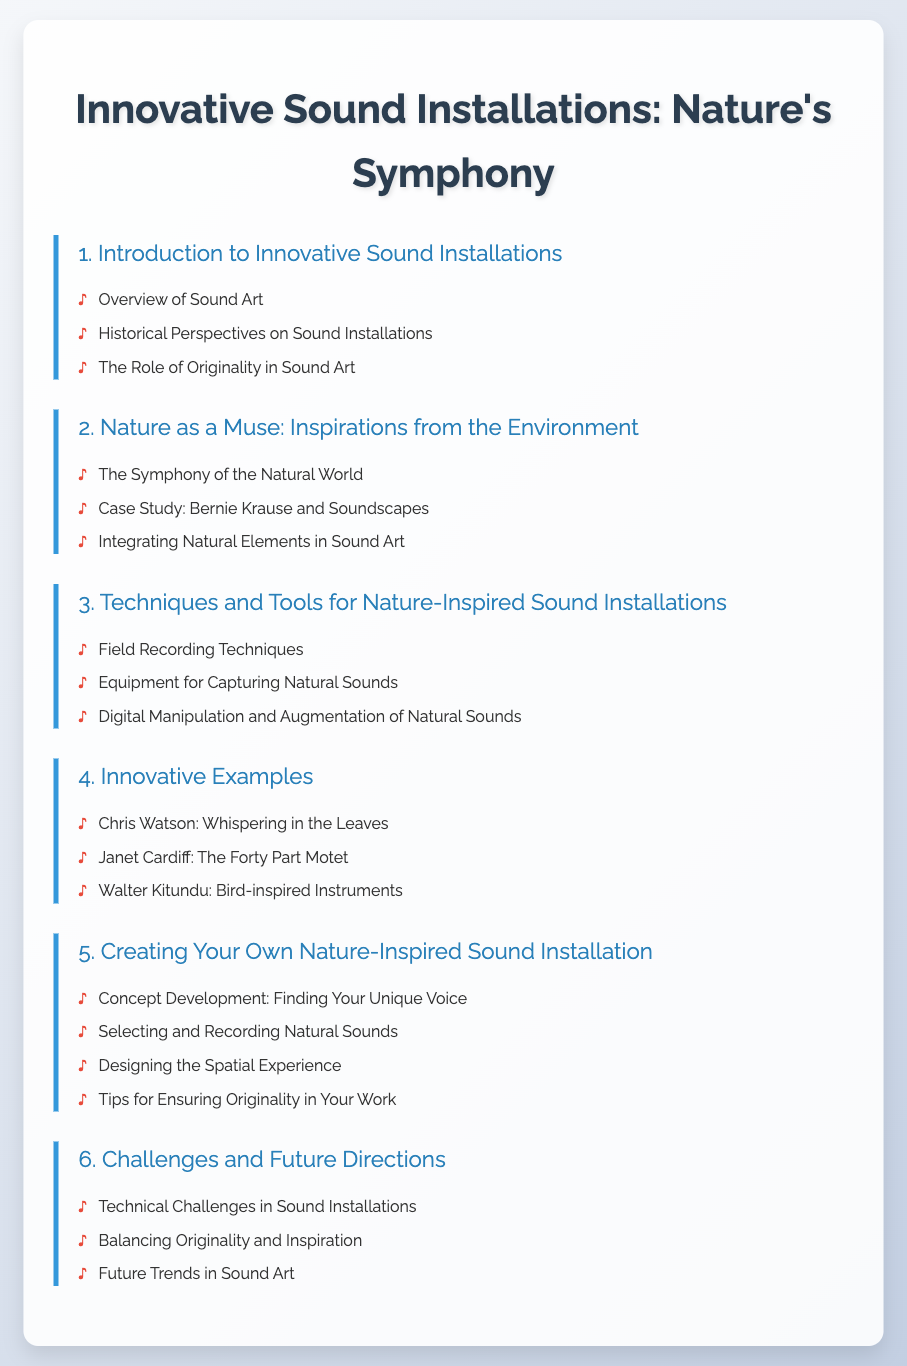what is the title of the document? The title listed at the top of the document clearly shows the main focus area it covers, which is "Innovative Sound Installations: Nature's Symphony."
Answer: Innovative Sound Installations: Nature's Symphony how many chapters are in the document? By counting the number of distinct chapters provided in the Table of Contents, you can determine the total, which is six.
Answer: 6 who is a case study highlighted in the second chapter? The document specifically mentions Bernie Krause in the context of soundscapes in the second chapter.
Answer: Bernie Krause what is covered in the fourth chapter? The fourth chapter focuses on innovative examples of sound installations, detailing specific artists and their work.
Answer: Innovative Examples which section emphasizes originality? The document mentions originality in both Chapter 1 and Chapter 5, highlighting its significance in sound art and practical creation.
Answer: The Role of Originality in Sound Art what is a technique mentioned for capturing natural sounds? The document refers to "Field Recording Techniques" as an approach for capturing sounds from nature.
Answer: Field Recording Techniques which artist is associated with "Whispering in the Leaves"? The document attributes this work to Chris Watson, indicating a notable example of sound art inspired by nature.
Answer: Chris Watson what is the final chapter about? The last chapter of the document discusses challenges faced in sound installations and future directions for the art form.
Answer: Challenges and Future Directions 